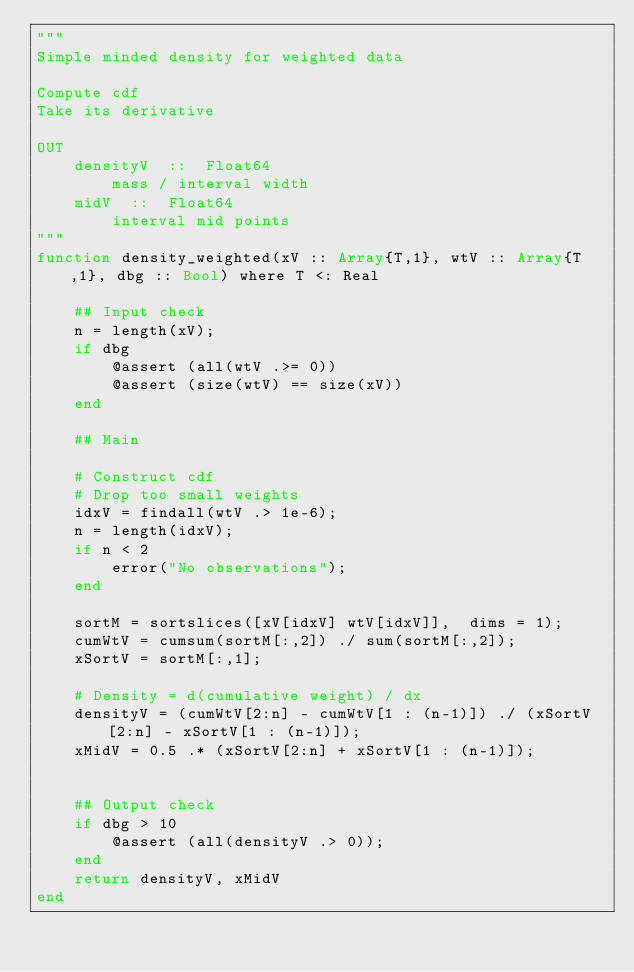Convert code to text. <code><loc_0><loc_0><loc_500><loc_500><_Julia_>"""
Simple minded density for weighted data

Compute cdf
Take its derivative

OUT
    densityV  ::  Float64
        mass / interval width
    midV  ::  Float64
        interval mid points
"""
function density_weighted(xV :: Array{T,1}, wtV :: Array{T,1}, dbg :: Bool) where T <: Real

	## Input check
	n = length(xV);
	if dbg
		@assert (all(wtV .>= 0))
		@assert (size(wtV) == size(xV))
	end

	## Main

	# Construct cdf
	# Drop too small weights
	idxV = findall(wtV .> 1e-6);
	n = length(idxV);
	if n < 2
		error("No observations");
	end

	sortM = sortslices([xV[idxV] wtV[idxV]],  dims = 1);
	cumWtV = cumsum(sortM[:,2]) ./ sum(sortM[:,2]);
	xSortV = sortM[:,1];

	# Density = d(cumulative weight) / dx
	densityV = (cumWtV[2:n] - cumWtV[1 : (n-1)]) ./ (xSortV[2:n] - xSortV[1 : (n-1)]);
	xMidV = 0.5 .* (xSortV[2:n] + xSortV[1 : (n-1)]);


	## Output check
	if dbg > 10
		@assert (all(densityV .> 0));
	end
	return densityV, xMidV
end
</code> 